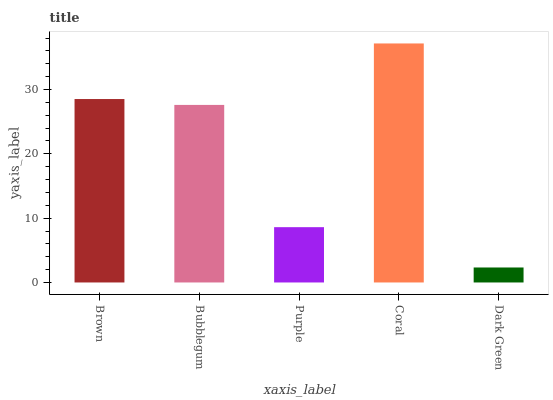Is Dark Green the minimum?
Answer yes or no. Yes. Is Coral the maximum?
Answer yes or no. Yes. Is Bubblegum the minimum?
Answer yes or no. No. Is Bubblegum the maximum?
Answer yes or no. No. Is Brown greater than Bubblegum?
Answer yes or no. Yes. Is Bubblegum less than Brown?
Answer yes or no. Yes. Is Bubblegum greater than Brown?
Answer yes or no. No. Is Brown less than Bubblegum?
Answer yes or no. No. Is Bubblegum the high median?
Answer yes or no. Yes. Is Bubblegum the low median?
Answer yes or no. Yes. Is Coral the high median?
Answer yes or no. No. Is Purple the low median?
Answer yes or no. No. 